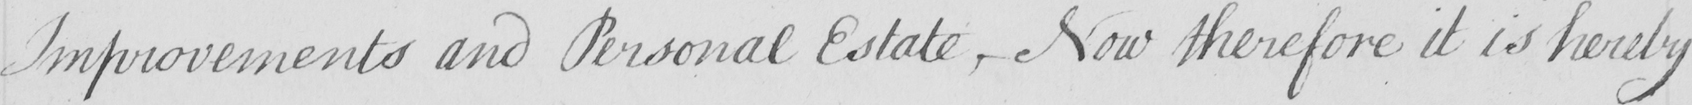What does this handwritten line say? Improvements and Personal Estate , Now therefore it is hereby 